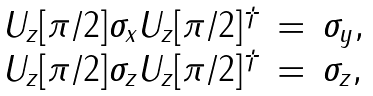Convert formula to latex. <formula><loc_0><loc_0><loc_500><loc_500>\begin{array} { r c l } U _ { z } [ \pi / 2 ] \sigma _ { x } U _ { z } [ \pi / 2 ] ^ { \dagger } & = & \sigma _ { y } , \\ U _ { z } [ \pi / 2 ] \sigma _ { z } U _ { z } [ \pi / 2 ] ^ { \dagger } & = & \sigma _ { z } , \end{array}</formula> 